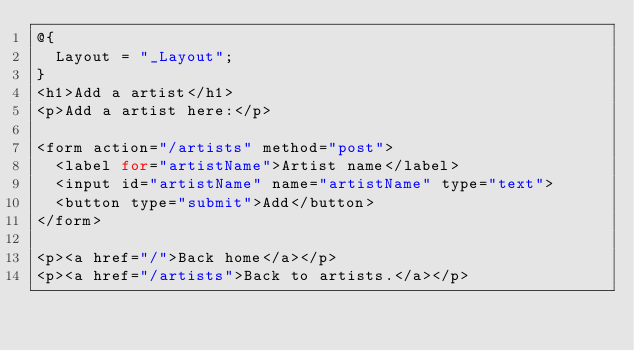<code> <loc_0><loc_0><loc_500><loc_500><_C#_>@{
  Layout = "_Layout";
}
<h1>Add a artist</h1>
<p>Add a artist here:</p>

<form action="/artists" method="post">
  <label for="artistName">Artist name</label>
  <input id="artistName" name="artistName" type="text">
  <button type="submit">Add</button>
</form>

<p><a href="/">Back home</a></p>
<p><a href="/artists">Back to artists.</a></p></code> 